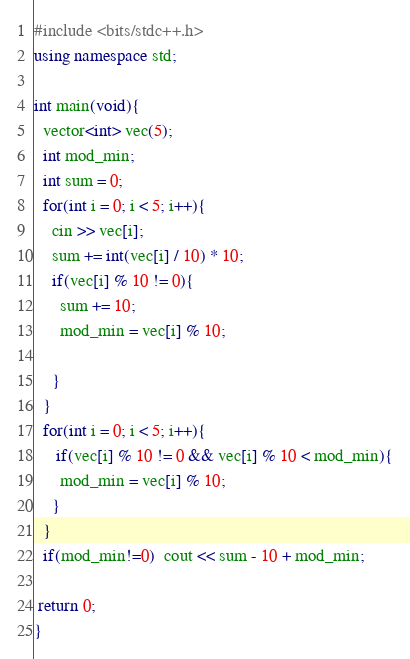Convert code to text. <code><loc_0><loc_0><loc_500><loc_500><_C++_>#include <bits/stdc++.h>
using namespace std;

int main(void){
  vector<int> vec(5);
  int mod_min;
  int sum = 0;
  for(int i = 0; i < 5; i++){
    cin >> vec[i];
    sum += int(vec[i] / 10) * 10;
    if(vec[i] % 10 != 0){
      sum += 10;
      mod_min = vec[i] % 10;
      
    }
  }
  for(int i = 0; i < 5; i++){
     if(vec[i] % 10 != 0 && vec[i] % 10 < mod_min){
      mod_min = vec[i] % 10;      
    }
  }
  if(mod_min!=0)  cout << sum - 10 + mod_min;
  
 return 0;
}</code> 